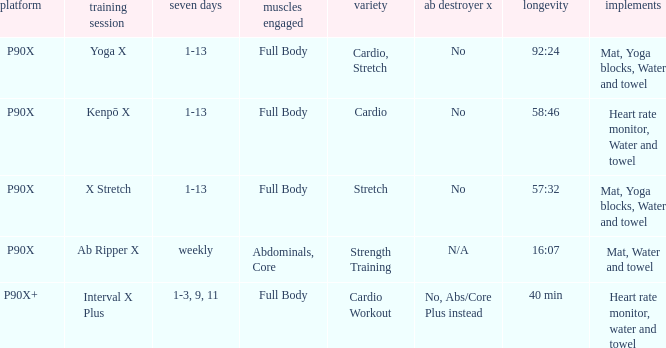What is the ab ripper x when exercise is x stretch? No. 